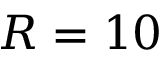<formula> <loc_0><loc_0><loc_500><loc_500>R = 1 0</formula> 